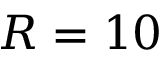<formula> <loc_0><loc_0><loc_500><loc_500>R = 1 0</formula> 